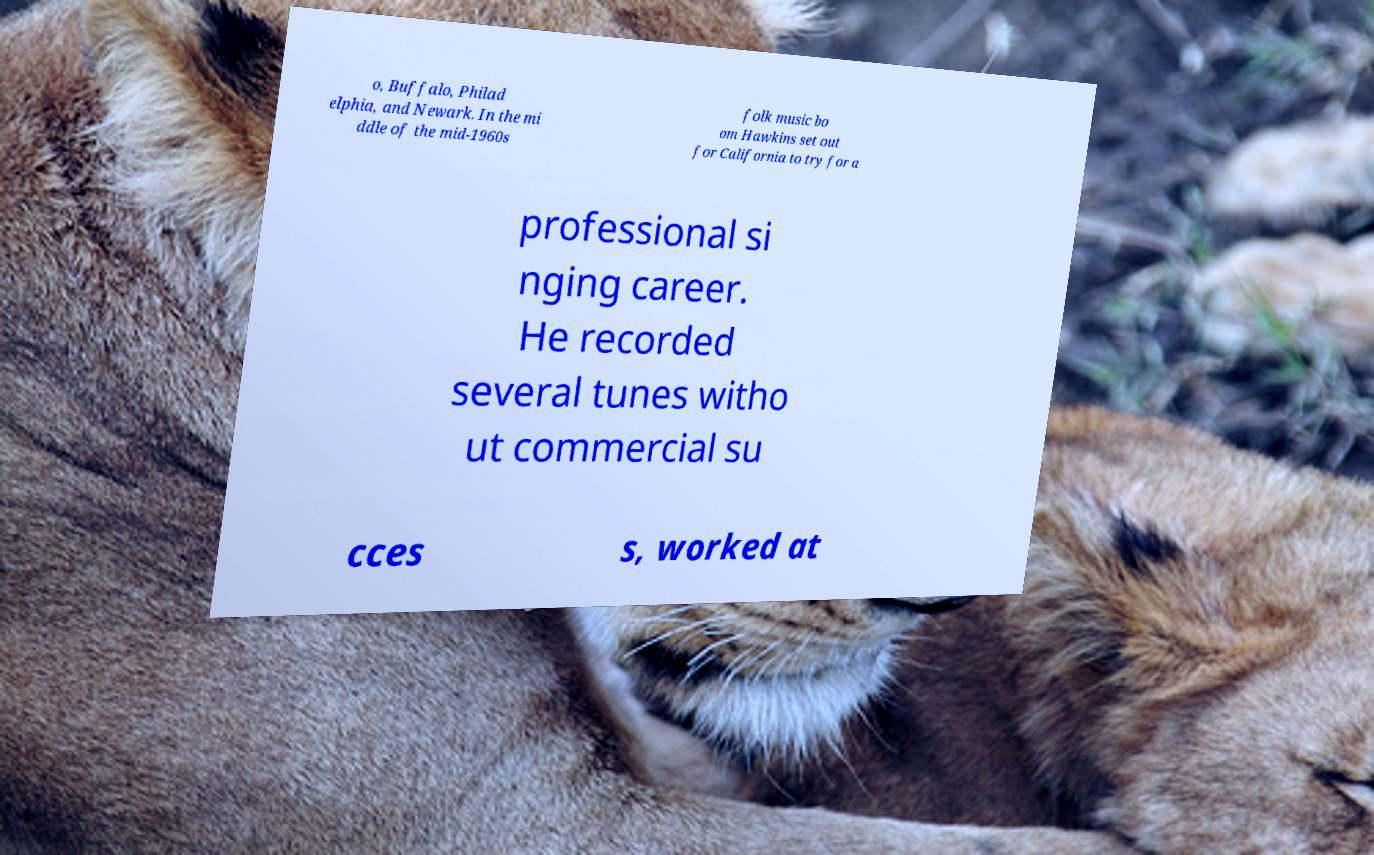I need the written content from this picture converted into text. Can you do that? o, Buffalo, Philad elphia, and Newark. In the mi ddle of the mid-1960s folk music bo om Hawkins set out for California to try for a professional si nging career. He recorded several tunes witho ut commercial su cces s, worked at 